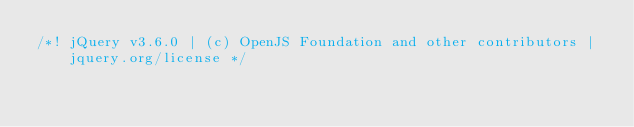Convert code to text. <code><loc_0><loc_0><loc_500><loc_500><_JavaScript_>/*! jQuery v3.6.0 | (c) OpenJS Foundation and other contributors | jquery.org/license */</code> 